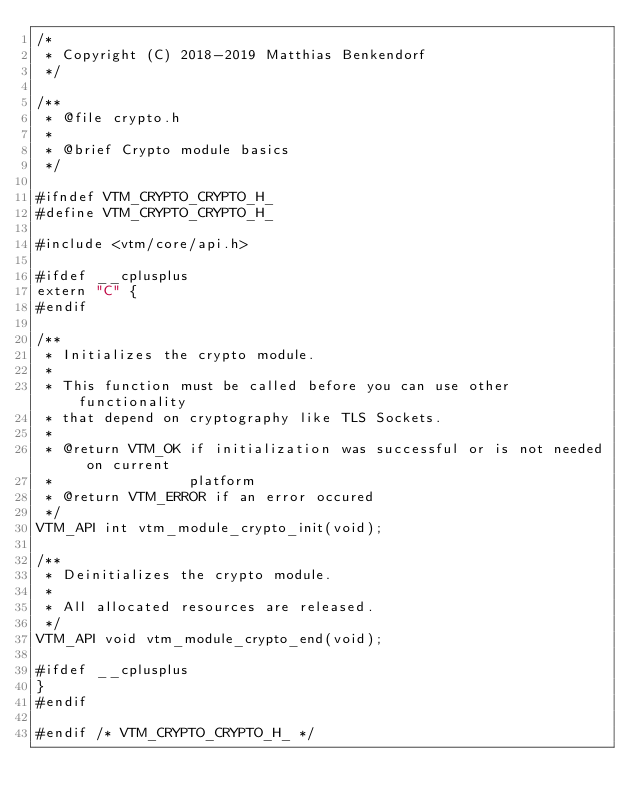Convert code to text. <code><loc_0><loc_0><loc_500><loc_500><_C_>/*
 * Copyright (C) 2018-2019 Matthias Benkendorf
 */

/**
 * @file crypto.h
 *
 * @brief Crypto module basics
 */

#ifndef VTM_CRYPTO_CRYPTO_H_
#define VTM_CRYPTO_CRYPTO_H_

#include <vtm/core/api.h>

#ifdef __cplusplus
extern "C" {
#endif

/**
 * Initializes the crypto module.
 *
 * This function must be called before you can use other functionality
 * that depend on cryptography like TLS Sockets.
 *
 * @return VTM_OK if initialization was successful or is not needed on current
 *                platform
 * @return VTM_ERROR if an error occured
 */
VTM_API int vtm_module_crypto_init(void);

/**
 * Deinitializes the crypto module.
 *
 * All allocated resources are released.
 */
VTM_API void vtm_module_crypto_end(void);

#ifdef __cplusplus
}
#endif

#endif /* VTM_CRYPTO_CRYPTO_H_ */
</code> 